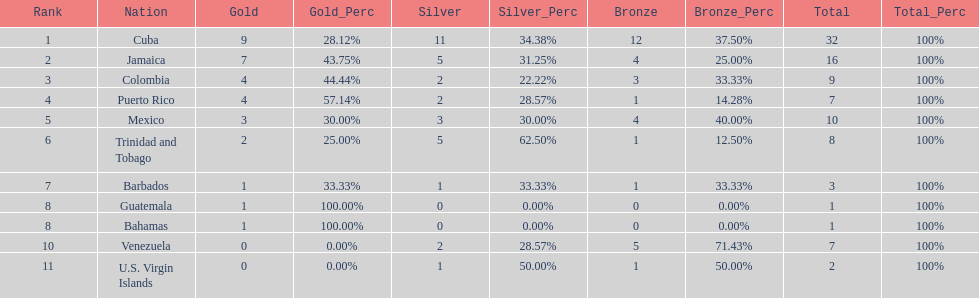Only team to have more than 30 medals Cuba. 